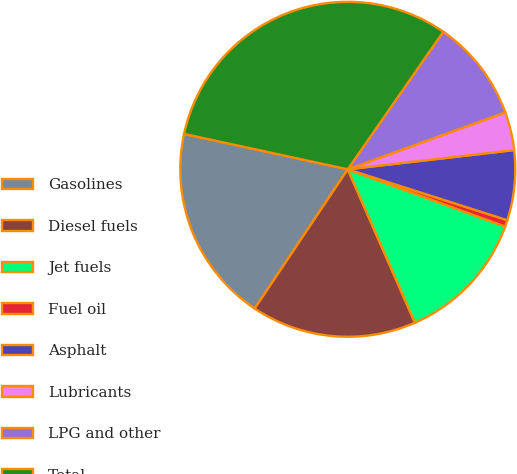Convert chart. <chart><loc_0><loc_0><loc_500><loc_500><pie_chart><fcel>Gasolines<fcel>Diesel fuels<fcel>Jet fuels<fcel>Fuel oil<fcel>Asphalt<fcel>Lubricants<fcel>LPG and other<fcel>Total<nl><fcel>19.01%<fcel>15.95%<fcel>12.88%<fcel>0.63%<fcel>6.75%<fcel>3.69%<fcel>9.82%<fcel>31.27%<nl></chart> 